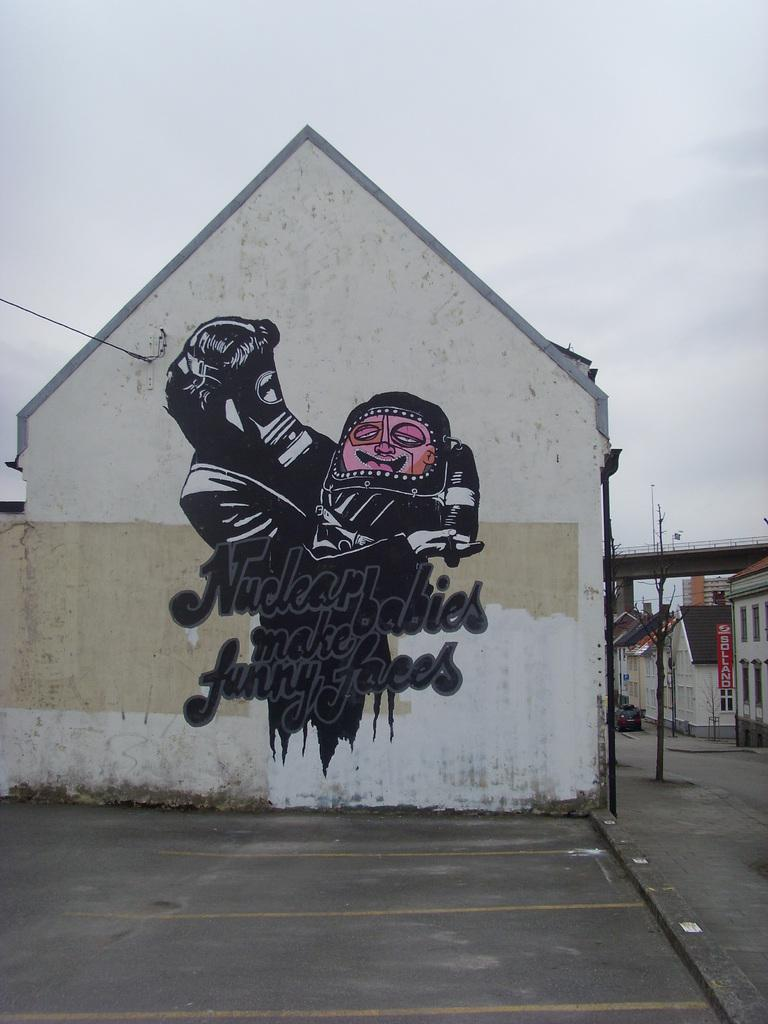<image>
Describe the image concisely. Nuclear babies make funny faces is painted onto the side of this building. 